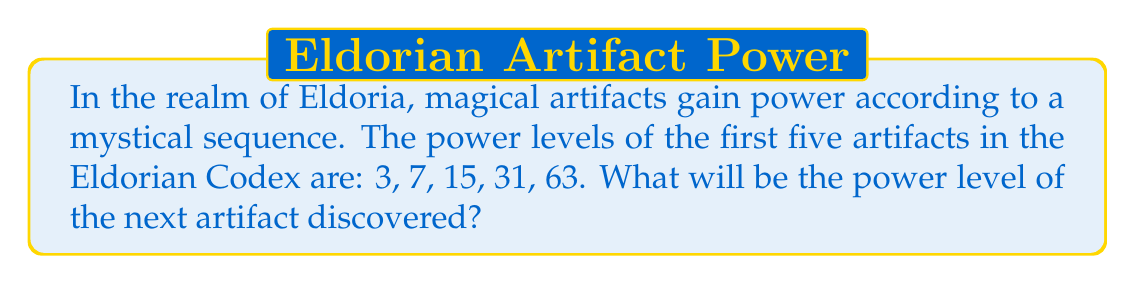Could you help me with this problem? Let's approach this mystical sequence step-by-step:

1) First, let's examine the differences between consecutive terms:
   $7 - 3 = 4$
   $15 - 7 = 8$
   $31 - 15 = 16$
   $63 - 31 = 32$

2) We can see that these differences form a sequence themselves: 4, 8, 16, 32

3) This sequence of differences is doubling each time: $4 \times 2 = 8$, $8 \times 2 = 16$, $16 \times 2 = 32$

4) So, we can deduce that the next difference will be: $32 \times 2 = 64$

5) To find the next term in our original sequence, we add this difference to the last known term:
   $63 + 64 = 127$

6) We can verify this pattern algebraically. The general term of this sequence can be written as:
   $a_n = 2^n - 1$, where $n$ starts at 2 (to get 3 as the first term)

7) Let's check:
   $a_2 = 2^2 - 1 = 4 - 1 = 3$
   $a_3 = 2^3 - 1 = 8 - 1 = 7$
   $a_4 = 2^4 - 1 = 16 - 1 = 15$
   $a_5 = 2^5 - 1 = 32 - 1 = 31$
   $a_6 = 2^6 - 1 = 64 - 1 = 63$

8) And for our next term:
   $a_7 = 2^7 - 1 = 128 - 1 = 127$

Thus, the power level of the next artifact in the Eldorian Codex will be 127.
Answer: 127 